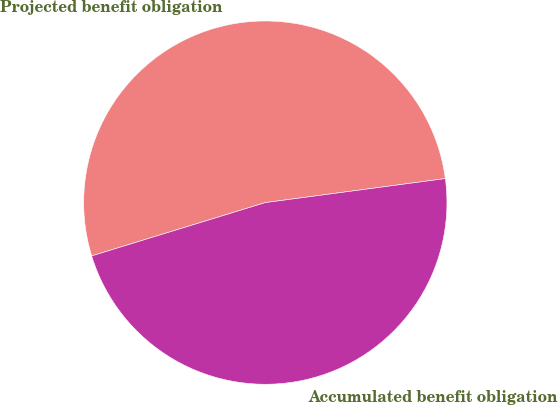Convert chart. <chart><loc_0><loc_0><loc_500><loc_500><pie_chart><fcel>Projected benefit obligation<fcel>Accumulated benefit obligation<nl><fcel>52.63%<fcel>47.37%<nl></chart> 